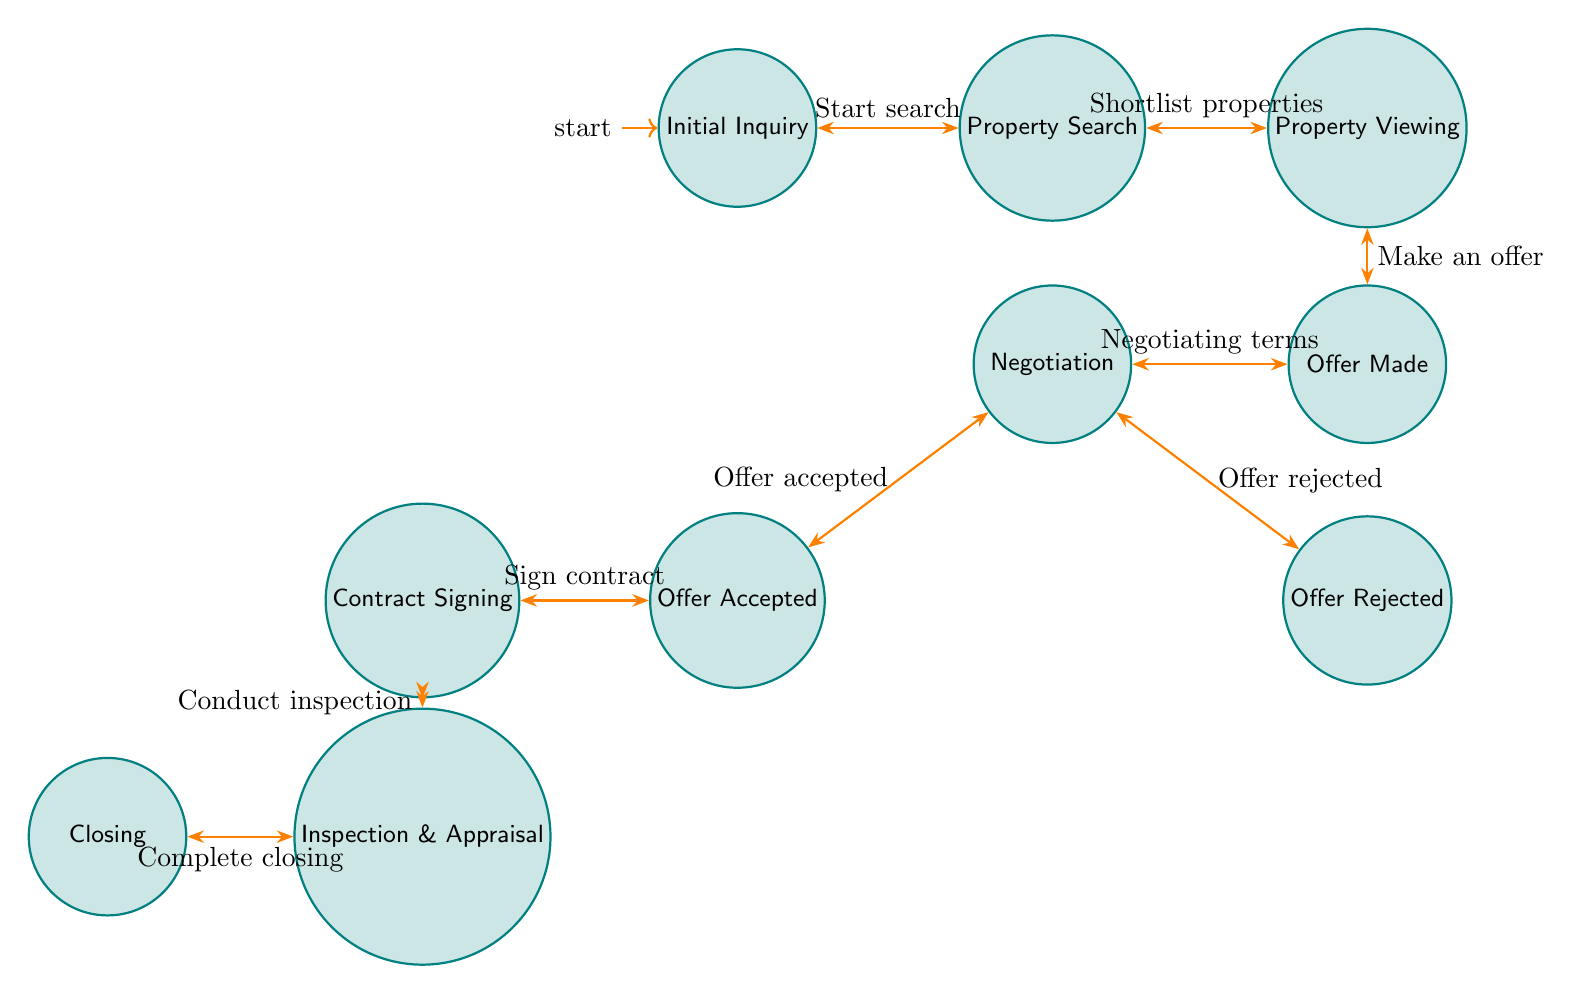What is the first state in the diagram? The first state is indicated by the "initial" marker and labeled "Initial Inquiry," which is where clients express interest.
Answer: Initial Inquiry How many states are present in the diagram? By counting the states listed in the diagram, there are a total of nine distinct states from "Initial Inquiry" to "Closing."
Answer: 9 What action leads from Property Viewing to Offer Made? The action connecting these two states is labeled "Make an offer," specifying the transition between viewing properties and deciding to make an offer.
Answer: Make an offer What happens if the offer is rejected? If the offer is rejected, the process branches to the "Offer Rejected" state, indicating that negotiations are unsuccessful and the client may need to reconsider their options.
Answer: Offer Rejected What is needed after the contract signing? After the successful signing of the contract, the next step is "Inspection and Appraisal," which is necessary before finalizing the property transaction.
Answer: Inspection and Appraisal What action is taken after the negotiation if the offer is accepted? When the negotiation results in an offer acceptance, the transition is to "Contract Signing," where both the client and seller agree to the purchase terms formally.
Answer: Sign contract Which state follows the "Inspection and Appraisal"? After completing the inspection and appraisal process, the transaction proceeds to the final state called "Closing," which denotes the completion of the sale.
Answer: Closing What is the relationship between Offer Made and Negotiation? The relationship is indicated by the action "Negotiating terms," showing that after making an offer, detailed negotiations take place between the client and seller.
Answer: Negotiating terms How does one transition from Property Search to Property Viewing? The transition requires the action "Shortlist properties," which signifies filtering down to suitable options for the client to view.
Answer: Shortlist properties 